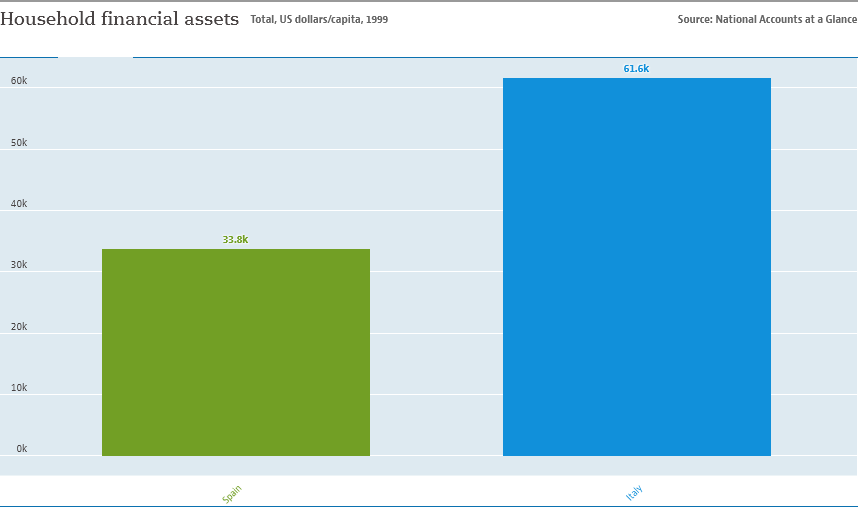Outline some significant characteristics in this image. The two bars have a difference of 27.8.. The value of the blue bar is 61.6.. 